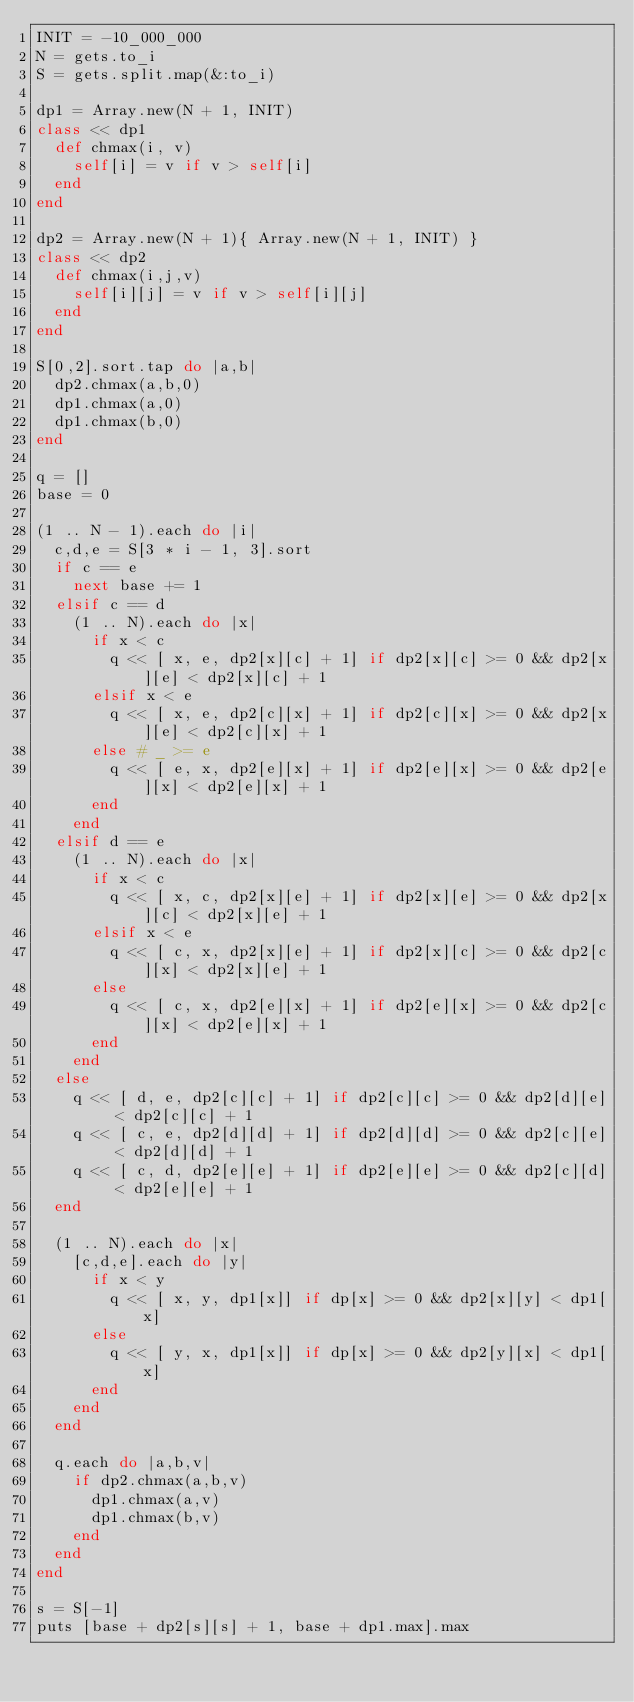Convert code to text. <code><loc_0><loc_0><loc_500><loc_500><_Ruby_>INIT = -10_000_000
N = gets.to_i
S = gets.split.map(&:to_i)

dp1 = Array.new(N + 1, INIT)
class << dp1
  def chmax(i, v)
    self[i] = v if v > self[i]
  end
end

dp2 = Array.new(N + 1){ Array.new(N + 1, INIT) }
class << dp2
  def chmax(i,j,v)
    self[i][j] = v if v > self[i][j]
  end
end

S[0,2].sort.tap do |a,b|
  dp2.chmax(a,b,0)
  dp1.chmax(a,0)
  dp1.chmax(b,0)
end

q = []
base = 0

(1 .. N - 1).each do |i|
  c,d,e = S[3 * i - 1, 3].sort
  if c == e
    next base += 1
  elsif c == d
    (1 .. N).each do |x|
      if x < c
        q << [ x, e, dp2[x][c] + 1] if dp2[x][c] >= 0 && dp2[x][e] < dp2[x][c] + 1
      elsif x < e
        q << [ x, e, dp2[c][x] + 1] if dp2[c][x] >= 0 && dp2[x][e] < dp2[c][x] + 1
      else # _ >= e
        q << [ e, x, dp2[e][x] + 1] if dp2[e][x] >= 0 && dp2[e][x] < dp2[e][x] + 1
      end
    end
  elsif d == e
    (1 .. N).each do |x|
      if x < c
        q << [ x, c, dp2[x][e] + 1] if dp2[x][e] >= 0 && dp2[x][c] < dp2[x][e] + 1
      elsif x < e
        q << [ c, x, dp2[x][e] + 1] if dp2[x][c] >= 0 && dp2[c][x] < dp2[x][e] + 1
      else
        q << [ c, x, dp2[e][x] + 1] if dp2[e][x] >= 0 && dp2[c][x] < dp2[e][x] + 1
      end
    end
  else
    q << [ d, e, dp2[c][c] + 1] if dp2[c][c] >= 0 && dp2[d][e] < dp2[c][c] + 1
    q << [ c, e, dp2[d][d] + 1] if dp2[d][d] >= 0 && dp2[c][e] < dp2[d][d] + 1
    q << [ c, d, dp2[e][e] + 1] if dp2[e][e] >= 0 && dp2[c][d] < dp2[e][e] + 1
  end

  (1 .. N).each do |x|
    [c,d,e].each do |y|
      if x < y
        q << [ x, y, dp1[x]] if dp[x] >= 0 && dp2[x][y] < dp1[x]
      else
        q << [ y, x, dp1[x]] if dp[x] >= 0 && dp2[y][x] < dp1[x]
      end
    end
  end

  q.each do |a,b,v|
    if dp2.chmax(a,b,v)
      dp1.chmax(a,v)
      dp1.chmax(b,v)
    end
  end
end

s = S[-1]
puts [base + dp2[s][s] + 1, base + dp1.max].max





</code> 